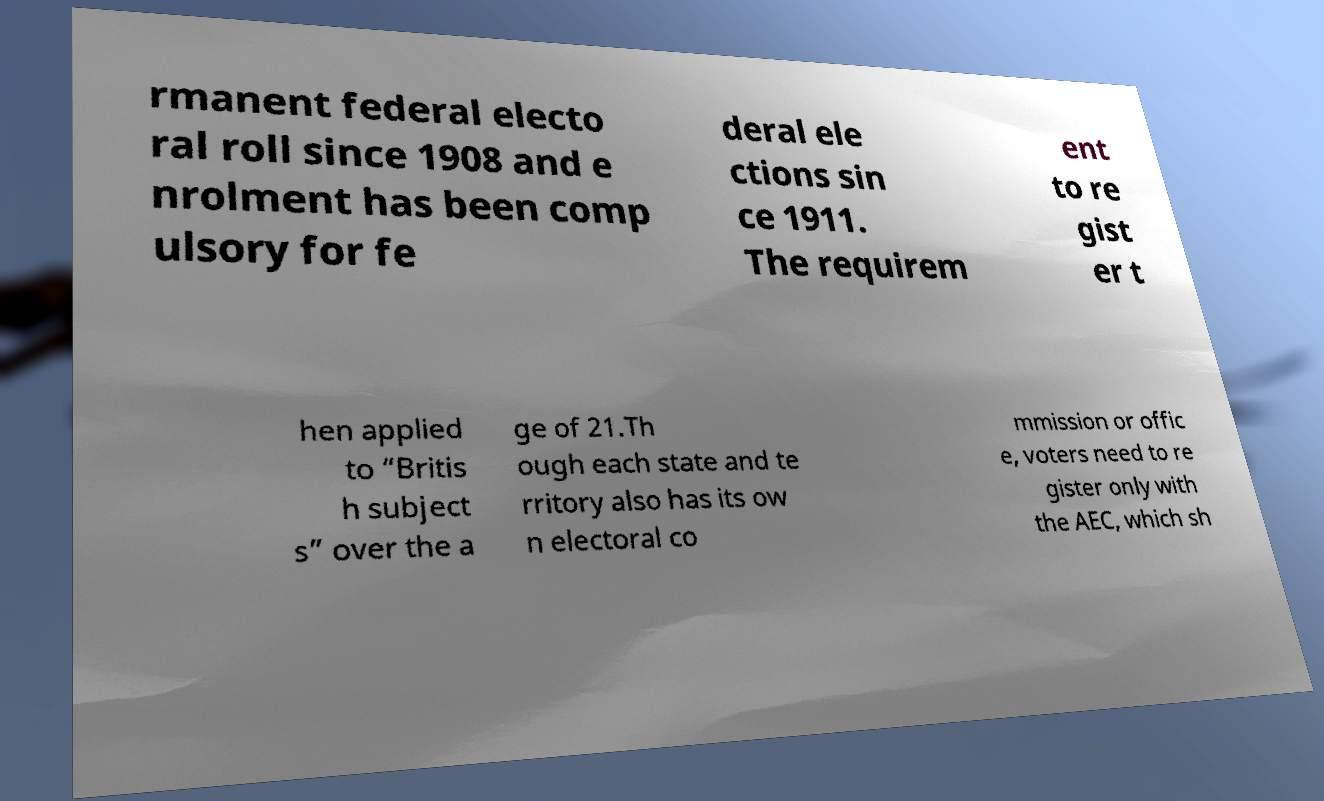Could you assist in decoding the text presented in this image and type it out clearly? rmanent federal electo ral roll since 1908 and e nrolment has been comp ulsory for fe deral ele ctions sin ce 1911. The requirem ent to re gist er t hen applied to “Britis h subject s” over the a ge of 21.Th ough each state and te rritory also has its ow n electoral co mmission or offic e, voters need to re gister only with the AEC, which sh 